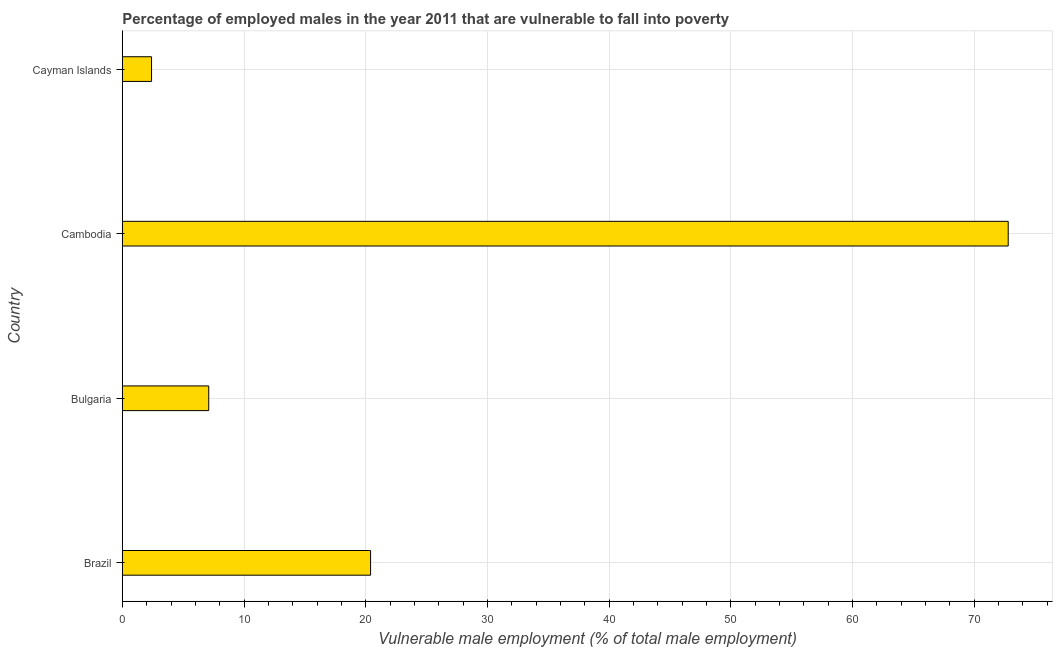Does the graph contain any zero values?
Your response must be concise. No. Does the graph contain grids?
Keep it short and to the point. Yes. What is the title of the graph?
Give a very brief answer. Percentage of employed males in the year 2011 that are vulnerable to fall into poverty. What is the label or title of the X-axis?
Provide a succinct answer. Vulnerable male employment (% of total male employment). What is the percentage of employed males who are vulnerable to fall into poverty in Brazil?
Make the answer very short. 20.4. Across all countries, what is the maximum percentage of employed males who are vulnerable to fall into poverty?
Ensure brevity in your answer.  72.8. Across all countries, what is the minimum percentage of employed males who are vulnerable to fall into poverty?
Offer a very short reply. 2.4. In which country was the percentage of employed males who are vulnerable to fall into poverty maximum?
Give a very brief answer. Cambodia. In which country was the percentage of employed males who are vulnerable to fall into poverty minimum?
Provide a succinct answer. Cayman Islands. What is the sum of the percentage of employed males who are vulnerable to fall into poverty?
Your answer should be very brief. 102.7. What is the difference between the percentage of employed males who are vulnerable to fall into poverty in Cambodia and Cayman Islands?
Provide a short and direct response. 70.4. What is the average percentage of employed males who are vulnerable to fall into poverty per country?
Your response must be concise. 25.68. What is the median percentage of employed males who are vulnerable to fall into poverty?
Your response must be concise. 13.75. What is the ratio of the percentage of employed males who are vulnerable to fall into poverty in Cambodia to that in Cayman Islands?
Provide a short and direct response. 30.33. Is the percentage of employed males who are vulnerable to fall into poverty in Brazil less than that in Cambodia?
Offer a very short reply. Yes. Is the difference between the percentage of employed males who are vulnerable to fall into poverty in Bulgaria and Cayman Islands greater than the difference between any two countries?
Ensure brevity in your answer.  No. What is the difference between the highest and the second highest percentage of employed males who are vulnerable to fall into poverty?
Offer a terse response. 52.4. Is the sum of the percentage of employed males who are vulnerable to fall into poverty in Brazil and Bulgaria greater than the maximum percentage of employed males who are vulnerable to fall into poverty across all countries?
Your answer should be very brief. No. What is the difference between the highest and the lowest percentage of employed males who are vulnerable to fall into poverty?
Ensure brevity in your answer.  70.4. In how many countries, is the percentage of employed males who are vulnerable to fall into poverty greater than the average percentage of employed males who are vulnerable to fall into poverty taken over all countries?
Keep it short and to the point. 1. What is the Vulnerable male employment (% of total male employment) in Brazil?
Provide a short and direct response. 20.4. What is the Vulnerable male employment (% of total male employment) in Bulgaria?
Provide a short and direct response. 7.1. What is the Vulnerable male employment (% of total male employment) in Cambodia?
Ensure brevity in your answer.  72.8. What is the Vulnerable male employment (% of total male employment) in Cayman Islands?
Your answer should be very brief. 2.4. What is the difference between the Vulnerable male employment (% of total male employment) in Brazil and Bulgaria?
Make the answer very short. 13.3. What is the difference between the Vulnerable male employment (% of total male employment) in Brazil and Cambodia?
Your answer should be compact. -52.4. What is the difference between the Vulnerable male employment (% of total male employment) in Bulgaria and Cambodia?
Give a very brief answer. -65.7. What is the difference between the Vulnerable male employment (% of total male employment) in Bulgaria and Cayman Islands?
Your answer should be compact. 4.7. What is the difference between the Vulnerable male employment (% of total male employment) in Cambodia and Cayman Islands?
Ensure brevity in your answer.  70.4. What is the ratio of the Vulnerable male employment (% of total male employment) in Brazil to that in Bulgaria?
Make the answer very short. 2.87. What is the ratio of the Vulnerable male employment (% of total male employment) in Brazil to that in Cambodia?
Your answer should be very brief. 0.28. What is the ratio of the Vulnerable male employment (% of total male employment) in Bulgaria to that in Cambodia?
Offer a terse response. 0.1. What is the ratio of the Vulnerable male employment (% of total male employment) in Bulgaria to that in Cayman Islands?
Keep it short and to the point. 2.96. What is the ratio of the Vulnerable male employment (% of total male employment) in Cambodia to that in Cayman Islands?
Ensure brevity in your answer.  30.33. 